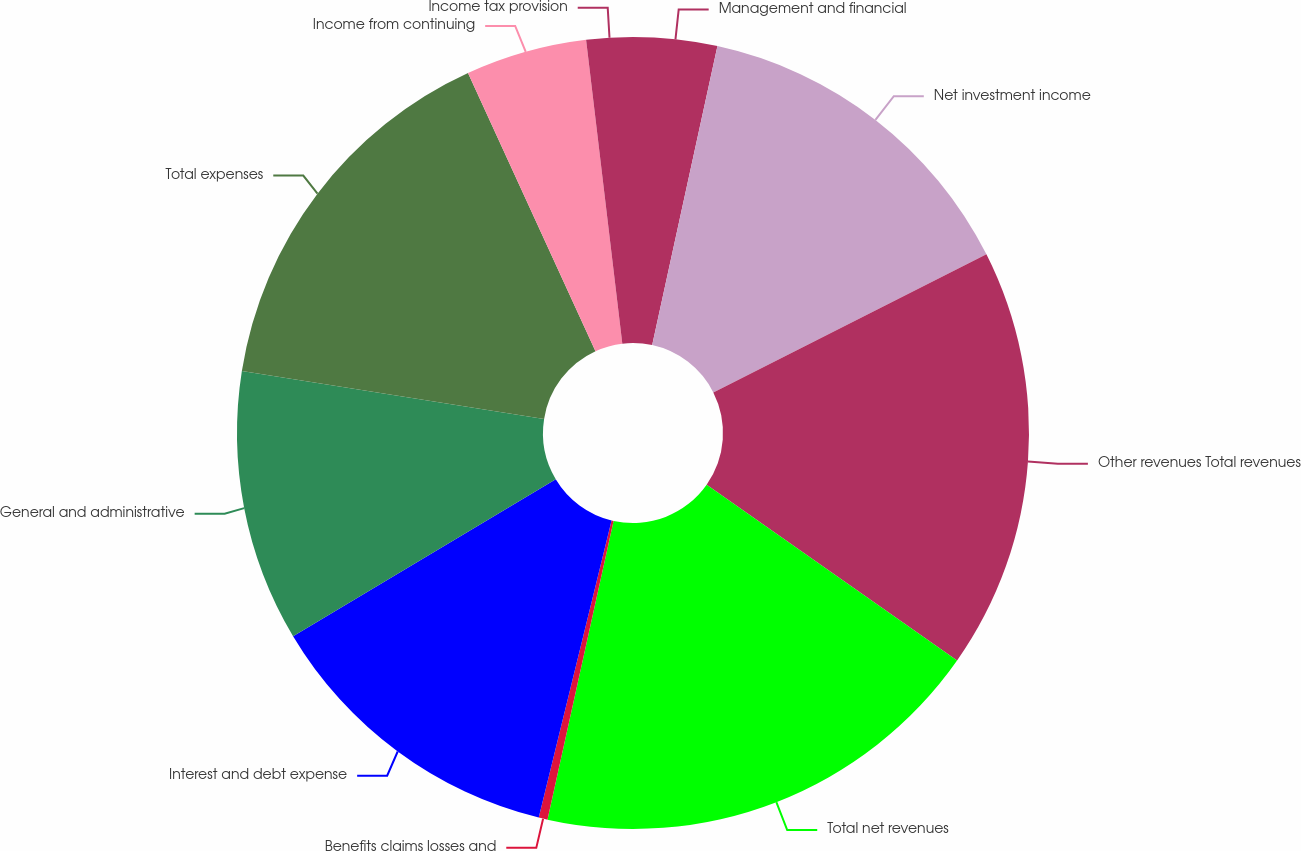Convert chart to OTSL. <chart><loc_0><loc_0><loc_500><loc_500><pie_chart><fcel>Management and financial<fcel>Net investment income<fcel>Other revenues Total revenues<fcel>Total net revenues<fcel>Benefits claims losses and<fcel>Interest and debt expense<fcel>General and administrative<fcel>Total expenses<fcel>Income from continuing<fcel>Income tax provision<nl><fcel>3.42%<fcel>14.13%<fcel>17.19%<fcel>18.72%<fcel>0.36%<fcel>12.6%<fcel>11.07%<fcel>15.66%<fcel>4.95%<fcel>1.89%<nl></chart> 